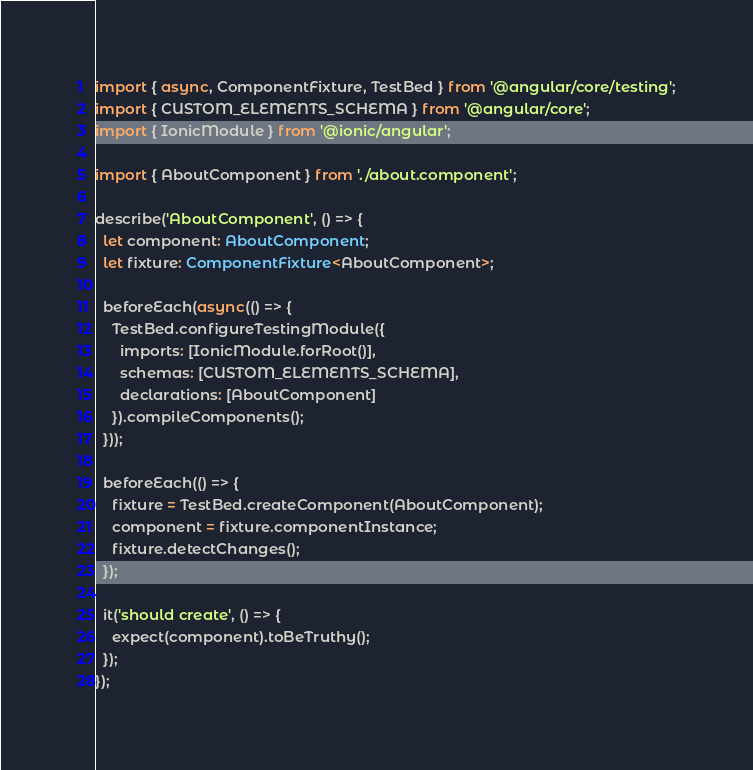Convert code to text. <code><loc_0><loc_0><loc_500><loc_500><_TypeScript_>import { async, ComponentFixture, TestBed } from '@angular/core/testing';
import { CUSTOM_ELEMENTS_SCHEMA } from '@angular/core';
import { IonicModule } from '@ionic/angular';

import { AboutComponent } from './about.component';

describe('AboutComponent', () => {
  let component: AboutComponent;
  let fixture: ComponentFixture<AboutComponent>;

  beforeEach(async(() => {
    TestBed.configureTestingModule({
      imports: [IonicModule.forRoot()],
      schemas: [CUSTOM_ELEMENTS_SCHEMA],
      declarations: [AboutComponent]
    }).compileComponents();
  }));

  beforeEach(() => {
    fixture = TestBed.createComponent(AboutComponent);
    component = fixture.componentInstance;
    fixture.detectChanges();
  });

  it('should create', () => {
    expect(component).toBeTruthy();
  });
});
</code> 